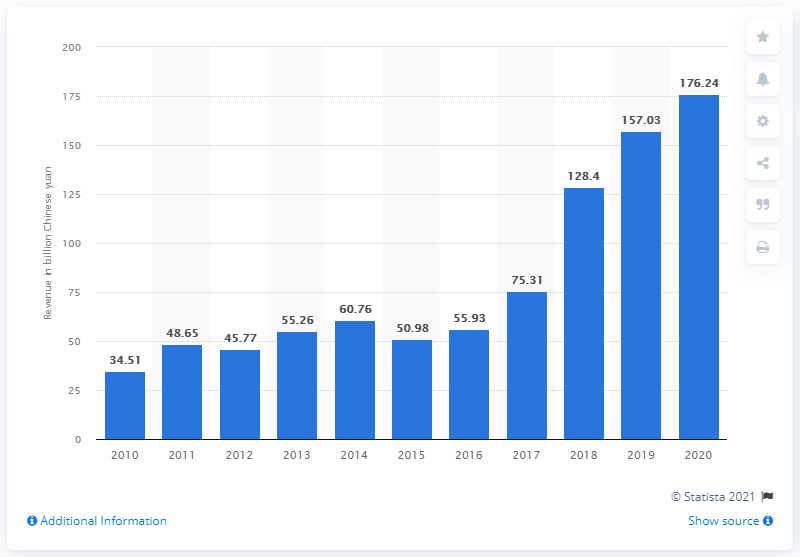Identify some key points in this picture. Anhui Conch Cement generated revenue of 176.24 million in the fiscal year of 2020. 